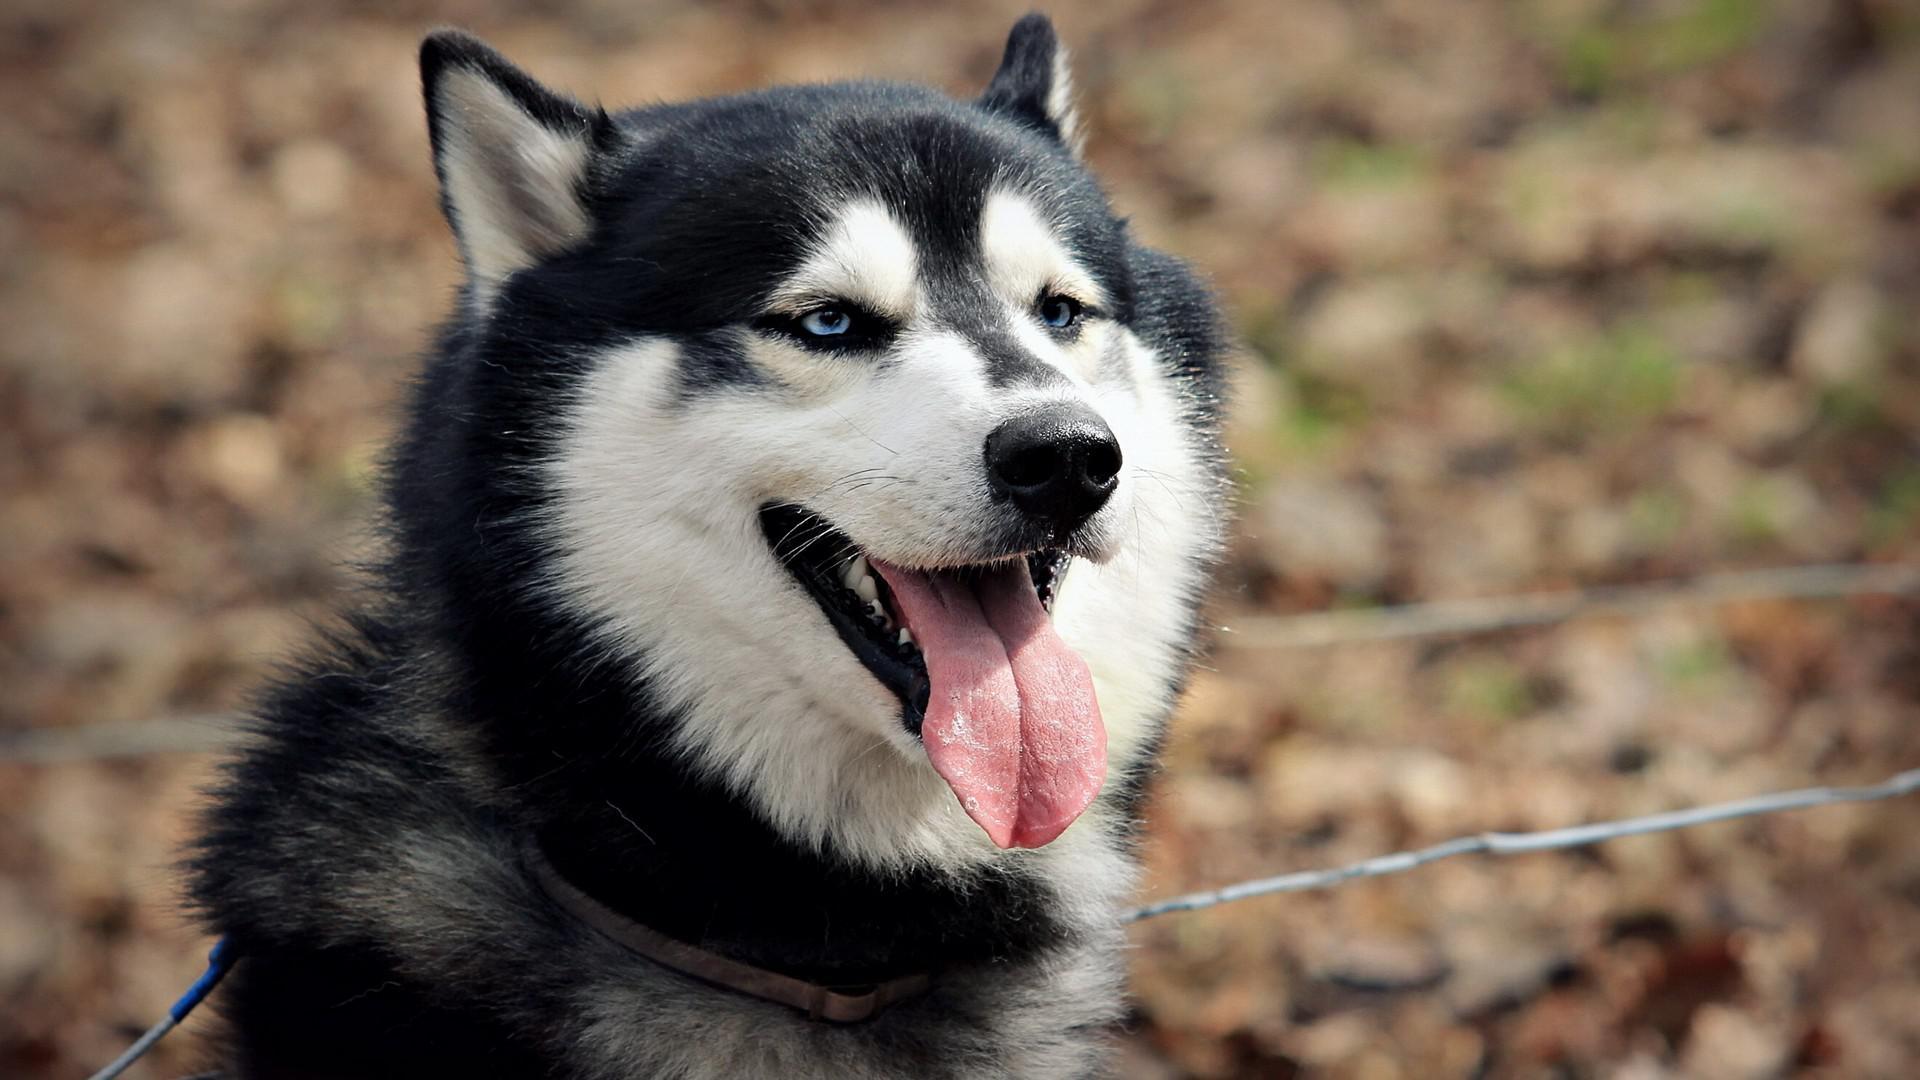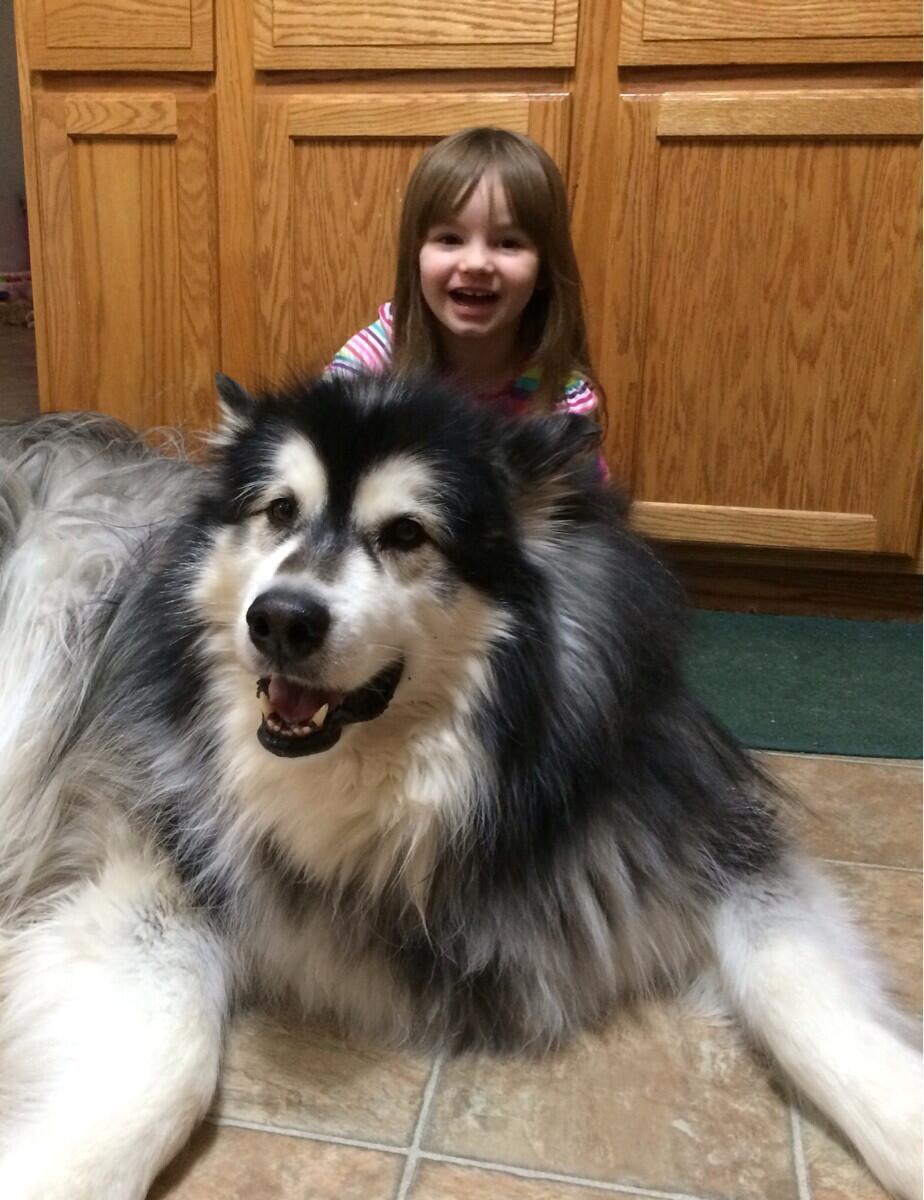The first image is the image on the left, the second image is the image on the right. Evaluate the accuracy of this statement regarding the images: "Each image contains just one dog, all dogs are black-and-white husky types, and the dog on the right is reclining with extended front paws.". Is it true? Answer yes or no. Yes. The first image is the image on the left, the second image is the image on the right. For the images displayed, is the sentence "The dog in the image on the right is indoors." factually correct? Answer yes or no. Yes. 